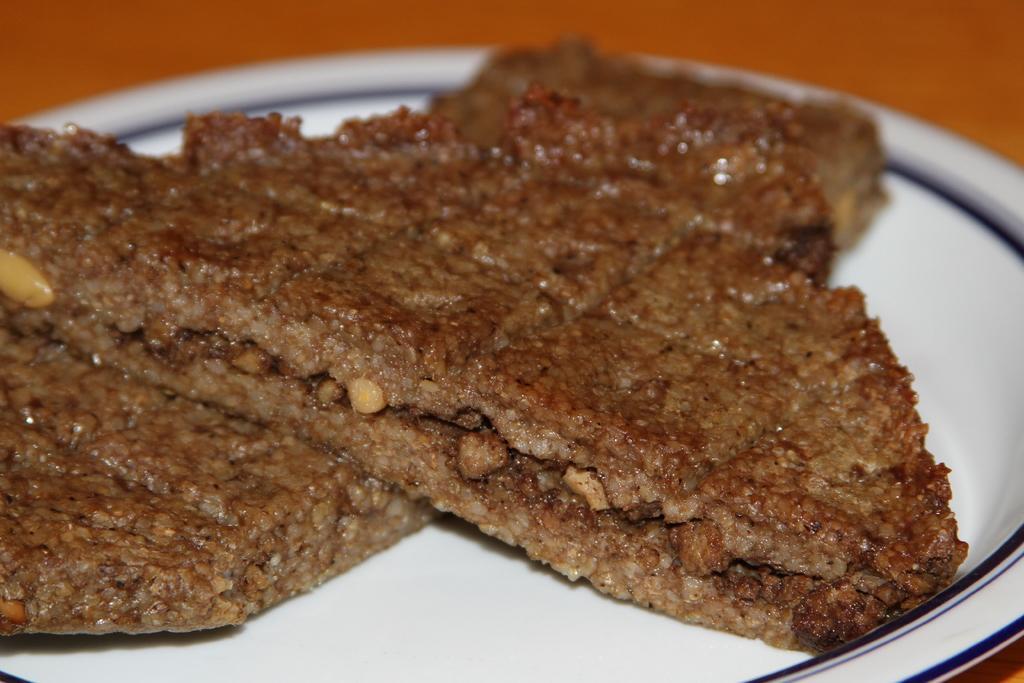Describe this image in one or two sentences. In the picture we can see a plate which is white in color with some cookies on it which are brown in color and with some dry fruits in it. 